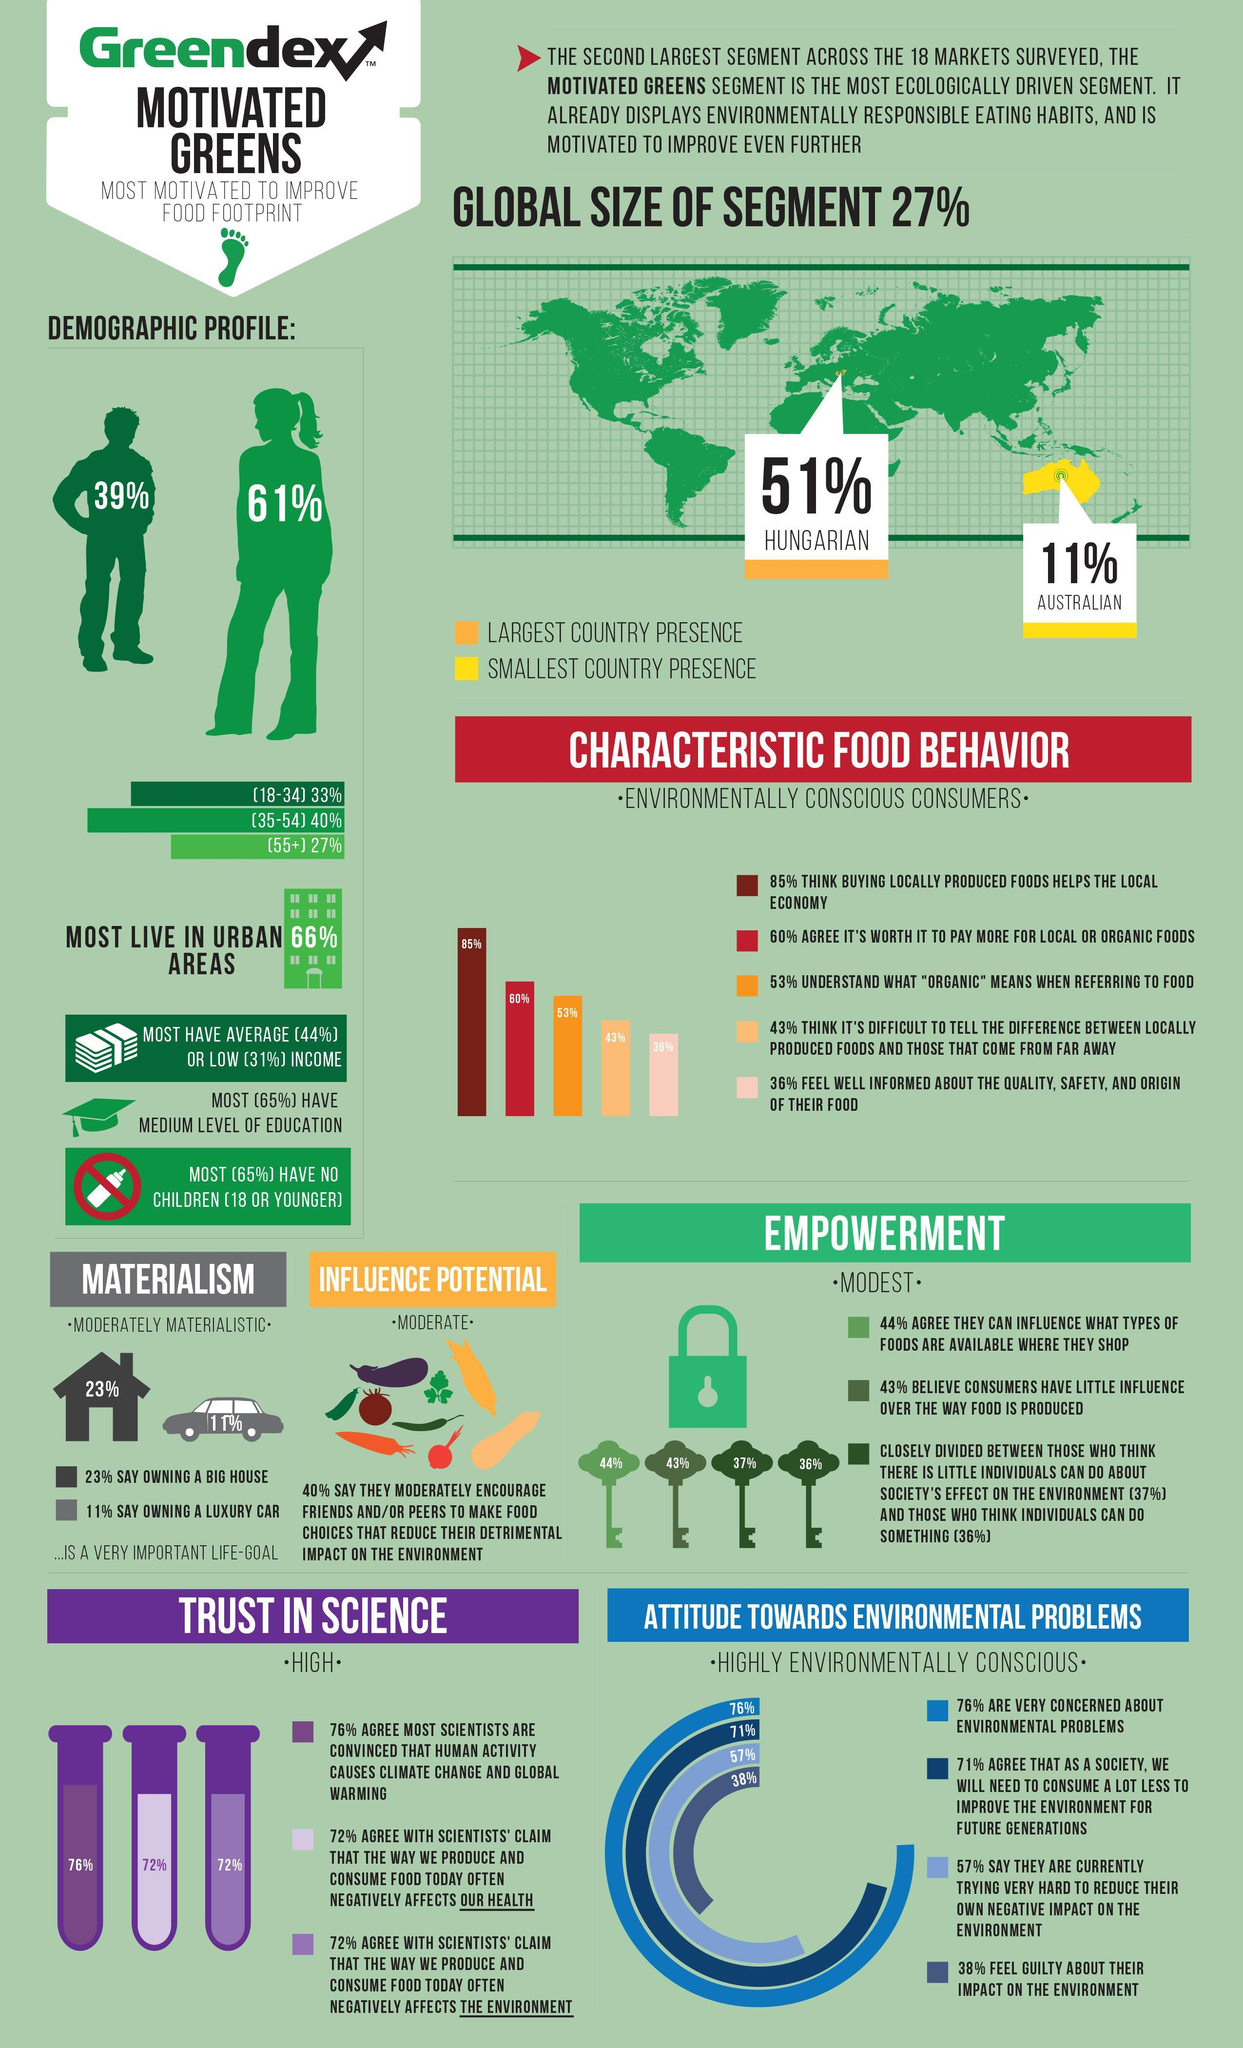What is the percentage of people not living in urban areas?
Answer the question with a short phrase. 34% What percentage of people have high incomes? 25% How many keys are in this infographic? 4 Which color is used to represent Australia-orange, yellow or red? yellow How many vegetables are in this infographic? 9 